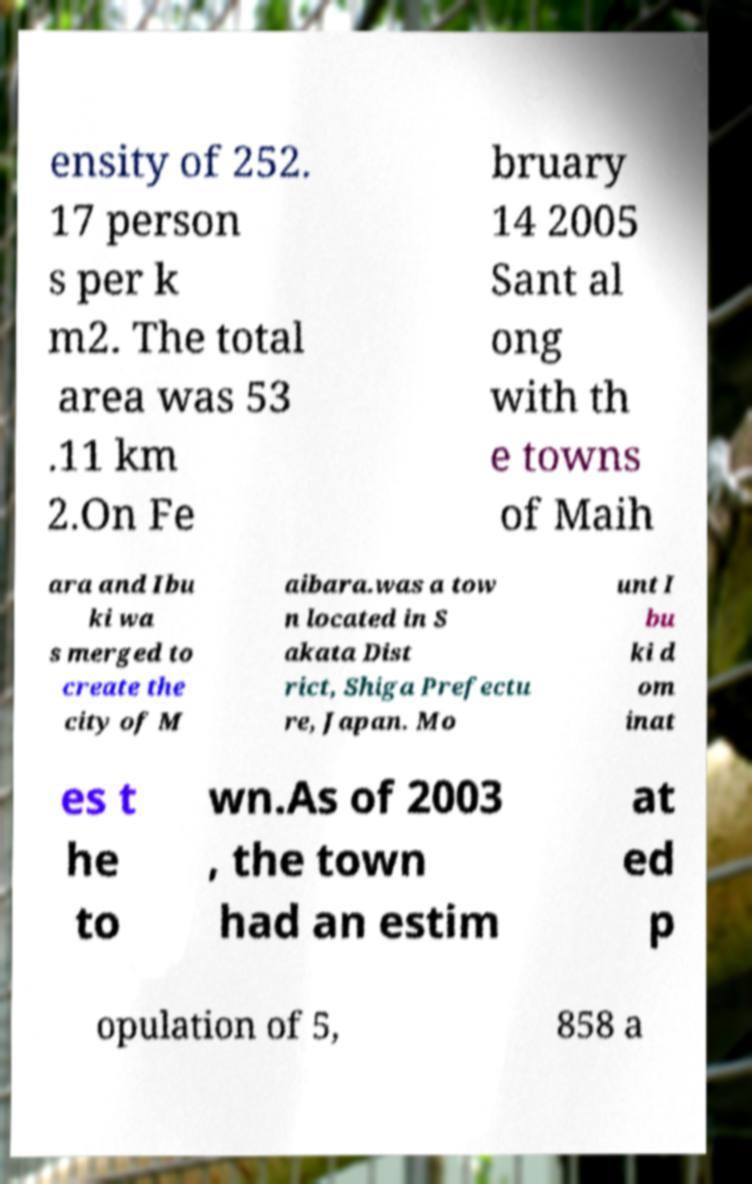Could you assist in decoding the text presented in this image and type it out clearly? ensity of 252. 17 person s per k m2. The total area was 53 .11 km 2.On Fe bruary 14 2005 Sant al ong with th e towns of Maih ara and Ibu ki wa s merged to create the city of M aibara.was a tow n located in S akata Dist rict, Shiga Prefectu re, Japan. Mo unt I bu ki d om inat es t he to wn.As of 2003 , the town had an estim at ed p opulation of 5, 858 a 